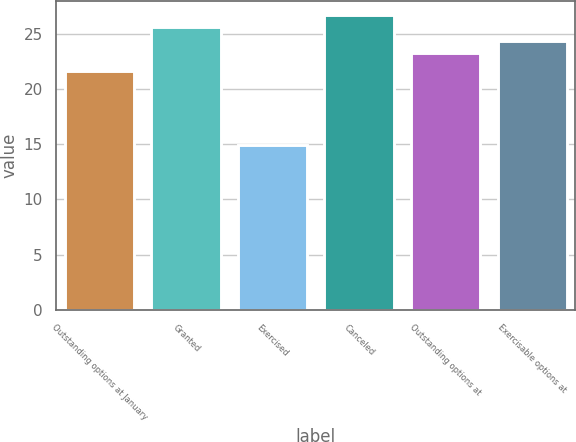Convert chart. <chart><loc_0><loc_0><loc_500><loc_500><bar_chart><fcel>Outstanding options at January<fcel>Granted<fcel>Exercised<fcel>Canceled<fcel>Outstanding options at<fcel>Exercisable options at<nl><fcel>21.63<fcel>25.59<fcel>14.89<fcel>26.67<fcel>23.28<fcel>24.36<nl></chart> 